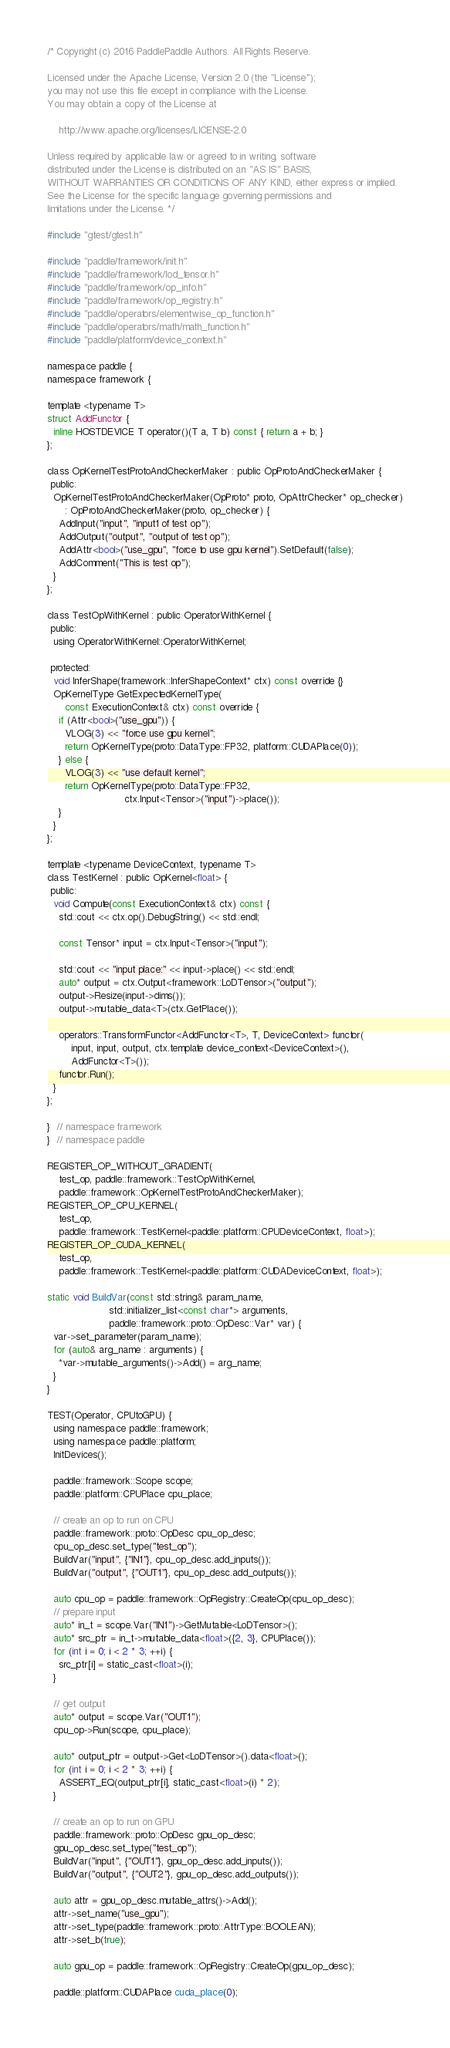Convert code to text. <code><loc_0><loc_0><loc_500><loc_500><_Cuda_>/* Copyright (c) 2016 PaddlePaddle Authors. All Rights Reserve.

Licensed under the Apache License, Version 2.0 (the "License");
you may not use this file except in compliance with the License.
You may obtain a copy of the License at

    http://www.apache.org/licenses/LICENSE-2.0

Unless required by applicable law or agreed to in writing, software
distributed under the License is distributed on an "AS IS" BASIS,
WITHOUT WARRANTIES OR CONDITIONS OF ANY KIND, either express or implied.
See the License for the specific language governing permissions and
limitations under the License. */

#include "gtest/gtest.h"

#include "paddle/framework/init.h"
#include "paddle/framework/lod_tensor.h"
#include "paddle/framework/op_info.h"
#include "paddle/framework/op_registry.h"
#include "paddle/operators/elementwise_op_function.h"
#include "paddle/operators/math/math_function.h"
#include "paddle/platform/device_context.h"

namespace paddle {
namespace framework {

template <typename T>
struct AddFunctor {
  inline HOSTDEVICE T operator()(T a, T b) const { return a + b; }
};

class OpKernelTestProtoAndCheckerMaker : public OpProtoAndCheckerMaker {
 public:
  OpKernelTestProtoAndCheckerMaker(OpProto* proto, OpAttrChecker* op_checker)
      : OpProtoAndCheckerMaker(proto, op_checker) {
    AddInput("input", "input1 of test op");
    AddOutput("output", "output of test op");
    AddAttr<bool>("use_gpu", "force to use gpu kernel").SetDefault(false);
    AddComment("This is test op");
  }
};

class TestOpWithKernel : public OperatorWithKernel {
 public:
  using OperatorWithKernel::OperatorWithKernel;

 protected:
  void InferShape(framework::InferShapeContext* ctx) const override {}
  OpKernelType GetExpectedKernelType(
      const ExecutionContext& ctx) const override {
    if (Attr<bool>("use_gpu")) {
      VLOG(3) << "force use gpu kernel";
      return OpKernelType(proto::DataType::FP32, platform::CUDAPlace(0));
    } else {
      VLOG(3) << "use default kernel";
      return OpKernelType(proto::DataType::FP32,
                          ctx.Input<Tensor>("input")->place());
    }
  }
};

template <typename DeviceContext, typename T>
class TestKernel : public OpKernel<float> {
 public:
  void Compute(const ExecutionContext& ctx) const {
    std::cout << ctx.op().DebugString() << std::endl;

    const Tensor* input = ctx.Input<Tensor>("input");

    std::cout << "input place:" << input->place() << std::endl;
    auto* output = ctx.Output<framework::LoDTensor>("output");
    output->Resize(input->dims());
    output->mutable_data<T>(ctx.GetPlace());

    operators::TransformFunctor<AddFunctor<T>, T, DeviceContext> functor(
        input, input, output, ctx.template device_context<DeviceContext>(),
        AddFunctor<T>());
    functor.Run();
  }
};

}  // namespace framework
}  // namespace paddle

REGISTER_OP_WITHOUT_GRADIENT(
    test_op, paddle::framework::TestOpWithKernel,
    paddle::framework::OpKernelTestProtoAndCheckerMaker);
REGISTER_OP_CPU_KERNEL(
    test_op,
    paddle::framework::TestKernel<paddle::platform::CPUDeviceContext, float>);
REGISTER_OP_CUDA_KERNEL(
    test_op,
    paddle::framework::TestKernel<paddle::platform::CUDADeviceContext, float>);

static void BuildVar(const std::string& param_name,
                     std::initializer_list<const char*> arguments,
                     paddle::framework::proto::OpDesc::Var* var) {
  var->set_parameter(param_name);
  for (auto& arg_name : arguments) {
    *var->mutable_arguments()->Add() = arg_name;
  }
}

TEST(Operator, CPUtoGPU) {
  using namespace paddle::framework;
  using namespace paddle::platform;
  InitDevices();

  paddle::framework::Scope scope;
  paddle::platform::CPUPlace cpu_place;

  // create an op to run on CPU
  paddle::framework::proto::OpDesc cpu_op_desc;
  cpu_op_desc.set_type("test_op");
  BuildVar("input", {"IN1"}, cpu_op_desc.add_inputs());
  BuildVar("output", {"OUT1"}, cpu_op_desc.add_outputs());

  auto cpu_op = paddle::framework::OpRegistry::CreateOp(cpu_op_desc);
  // prepare input
  auto* in_t = scope.Var("IN1")->GetMutable<LoDTensor>();
  auto* src_ptr = in_t->mutable_data<float>({2, 3}, CPUPlace());
  for (int i = 0; i < 2 * 3; ++i) {
    src_ptr[i] = static_cast<float>(i);
  }

  // get output
  auto* output = scope.Var("OUT1");
  cpu_op->Run(scope, cpu_place);

  auto* output_ptr = output->Get<LoDTensor>().data<float>();
  for (int i = 0; i < 2 * 3; ++i) {
    ASSERT_EQ(output_ptr[i], static_cast<float>(i) * 2);
  }

  // create an op to run on GPU
  paddle::framework::proto::OpDesc gpu_op_desc;
  gpu_op_desc.set_type("test_op");
  BuildVar("input", {"OUT1"}, gpu_op_desc.add_inputs());
  BuildVar("output", {"OUT2"}, gpu_op_desc.add_outputs());

  auto attr = gpu_op_desc.mutable_attrs()->Add();
  attr->set_name("use_gpu");
  attr->set_type(paddle::framework::proto::AttrType::BOOLEAN);
  attr->set_b(true);

  auto gpu_op = paddle::framework::OpRegistry::CreateOp(gpu_op_desc);

  paddle::platform::CUDAPlace cuda_place(0);</code> 